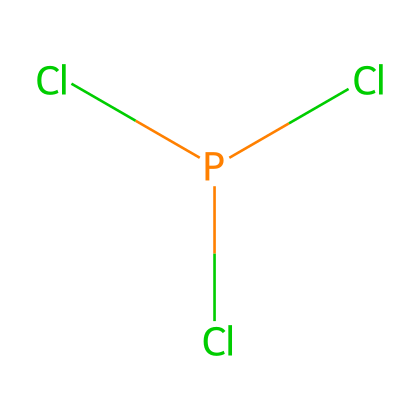What is the molecular formula of this compound? The molecular formula can be determined by identifying the atoms present in the SMILES representation. The structure “P(Cl)(Cl)Cl” indicates one phosphorus atom and three chlorine atoms. Therefore, combining these gives the molecular formula PCl3.
Answer: PCl3 How many total atoms are in phosphorus trichloride? To find the total number of atoms, count the individual atoms from the molecular formula PCl3. There is 1 phosphorus atom and 3 chlorine atoms, resulting in a total of 4 atoms.
Answer: 4 What type of hybridization is present in phosphorus trichloride? The phosphorus atom in PCl3 undergoes sp3 hybridization due to the presence of three bonding pairs with chlorine and a lone pair of electrons, leading to a tetrahedral arrangement.
Answer: sp3 What is the geometry of phosphorus trichloride? The molecule PCl3 has a tetrahedral shape based on its sp3 hybridization, but due to the presence of a lone pair on phosphorus, the actual molecular geometry is trigonal pyramidal.
Answer: trigonal pyramidal How does phosphorus trichloride function as a precursor in organophosphorus chemistry? Phosphorus trichloride acts as an important reagent and precursor in organophosphorus chemistry by introducing phosphorus into organic molecules through various reactions, such as converting alcohols to chlorophosphonates or phosphites.
Answer: reagent What characteristic property of phosphorus trichloride makes it useful in synthesis? Phosphorus trichloride is a reactive compound due to its ability to form P—Cl bonds that can be replaced or hydrolyzed in chemical reactions, allowing it to create diverse organophosphorus compounds.
Answer: reactive 